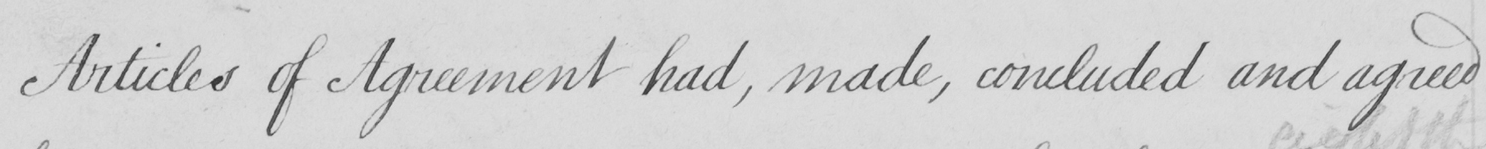What text is written in this handwritten line? Articles of Agreement had , made , concluded and agreed 